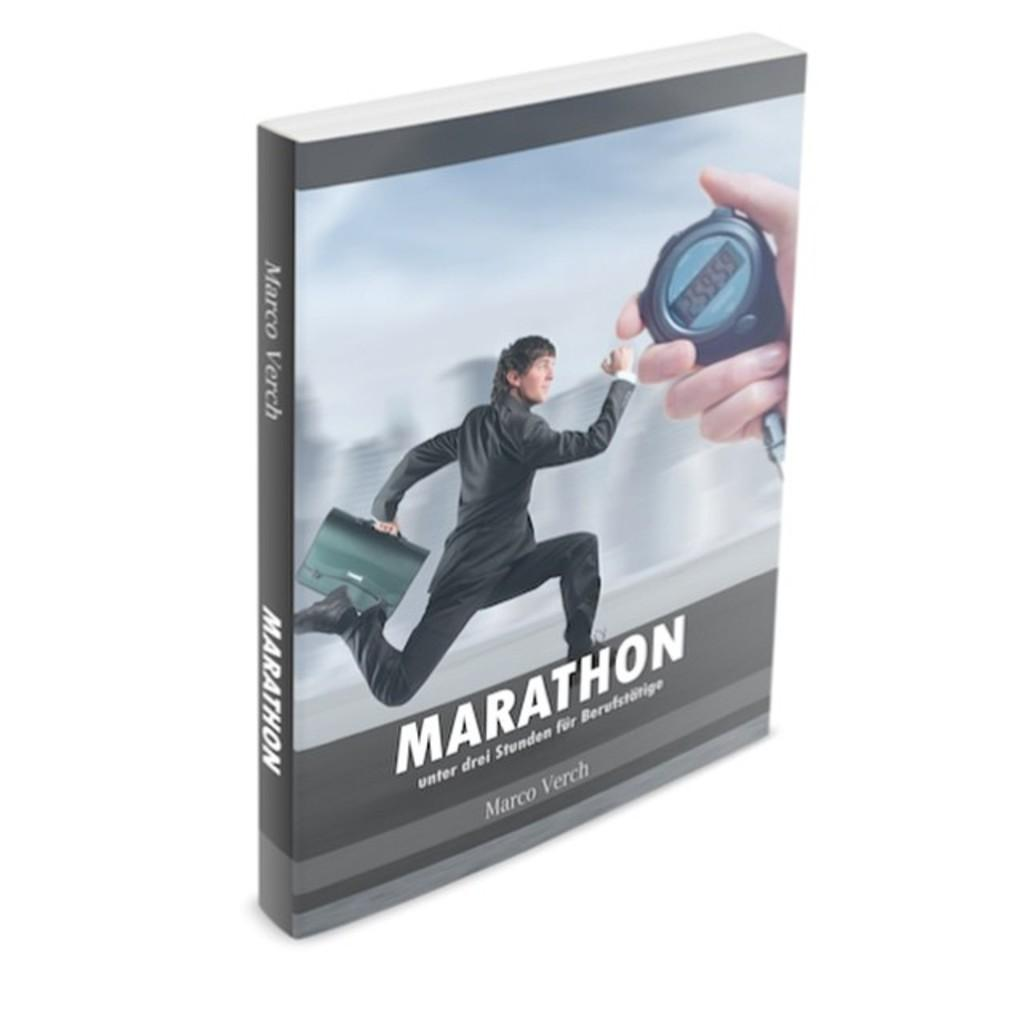<image>
Present a compact description of the photo's key features. A book called Marathon shows a running man and a stopwatch on the cover. 